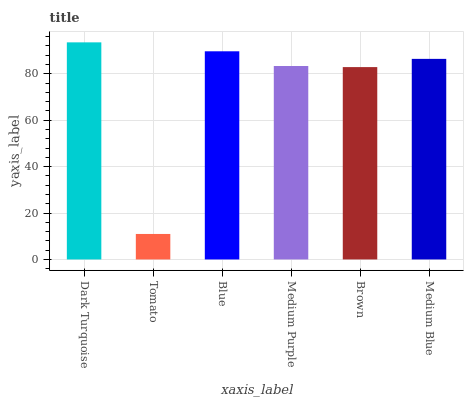Is Tomato the minimum?
Answer yes or no. Yes. Is Dark Turquoise the maximum?
Answer yes or no. Yes. Is Blue the minimum?
Answer yes or no. No. Is Blue the maximum?
Answer yes or no. No. Is Blue greater than Tomato?
Answer yes or no. Yes. Is Tomato less than Blue?
Answer yes or no. Yes. Is Tomato greater than Blue?
Answer yes or no. No. Is Blue less than Tomato?
Answer yes or no. No. Is Medium Blue the high median?
Answer yes or no. Yes. Is Medium Purple the low median?
Answer yes or no. Yes. Is Blue the high median?
Answer yes or no. No. Is Brown the low median?
Answer yes or no. No. 